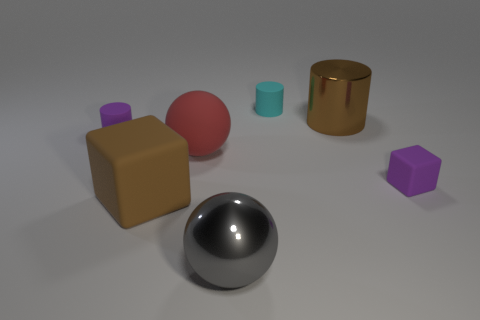Do the cyan thing and the big brown object that is to the right of the large red matte sphere have the same shape?
Your answer should be compact. Yes. There is a large rubber thing that is the same color as the metallic cylinder; what is its shape?
Ensure brevity in your answer.  Cube. What number of tiny cylinders are there?
Make the answer very short. 2. How many spheres are cyan objects or metallic objects?
Offer a terse response. 1. The other matte thing that is the same size as the red object is what color?
Provide a succinct answer. Brown. How many tiny rubber things are left of the brown metallic thing and in front of the brown shiny cylinder?
Your answer should be very brief. 1. What material is the large cube?
Keep it short and to the point. Rubber. How many things are small green metallic cylinders or big red matte objects?
Offer a terse response. 1. Is the size of the rubber cube that is right of the large gray metal object the same as the matte cylinder on the left side of the large red thing?
Give a very brief answer. Yes. What number of other things are the same size as the brown cylinder?
Offer a very short reply. 3. 